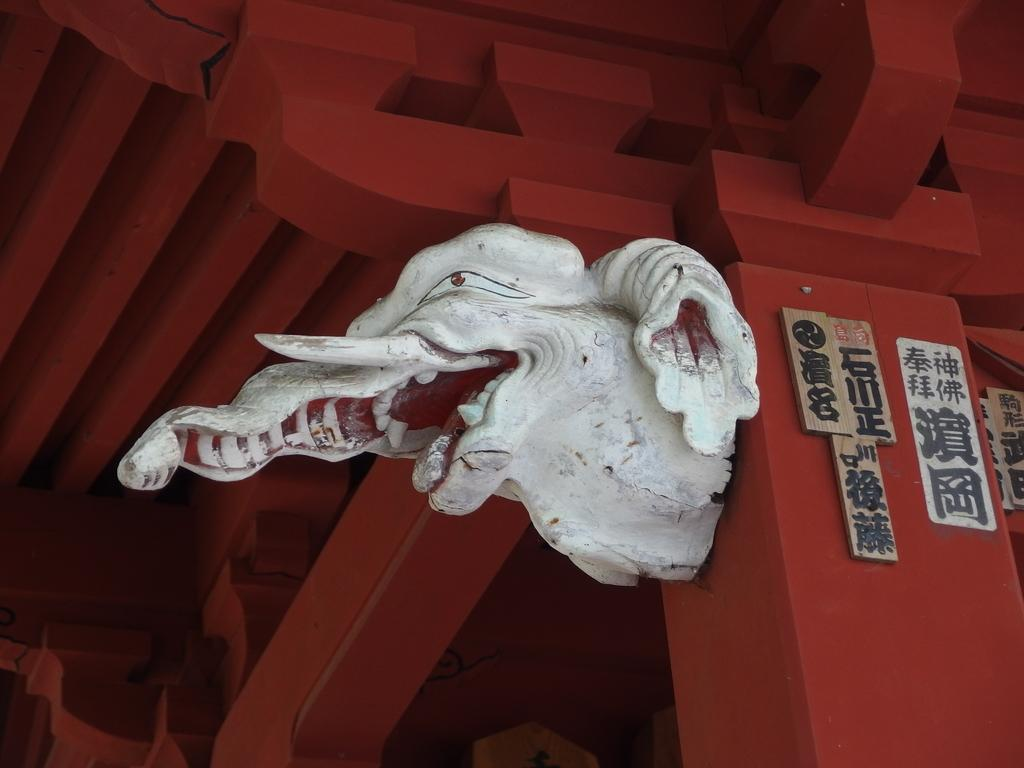What is the main subject in the center of the image? There is a toy in the center of the image. How is the toy positioned in the image? The toy is on a pillar. What can be seen on the right side of the image? There are boards and a pillar on the right side of the image. What architectural feature is visible in the background of the image? There is a roof visible in the background of the image. What type of space rock is visible in the image? There is no space rock present in the image; it features a toy on a pillar with boards and a roof visible in the background. 